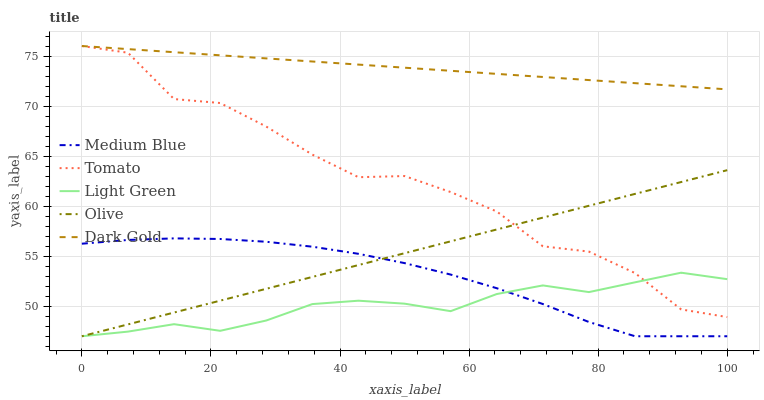Does Light Green have the minimum area under the curve?
Answer yes or no. Yes. Does Dark Gold have the maximum area under the curve?
Answer yes or no. Yes. Does Olive have the minimum area under the curve?
Answer yes or no. No. Does Olive have the maximum area under the curve?
Answer yes or no. No. Is Olive the smoothest?
Answer yes or no. Yes. Is Tomato the roughest?
Answer yes or no. Yes. Is Medium Blue the smoothest?
Answer yes or no. No. Is Medium Blue the roughest?
Answer yes or no. No. Does Olive have the lowest value?
Answer yes or no. Yes. Does Dark Gold have the lowest value?
Answer yes or no. No. Does Dark Gold have the highest value?
Answer yes or no. Yes. Does Olive have the highest value?
Answer yes or no. No. Is Olive less than Dark Gold?
Answer yes or no. Yes. Is Tomato greater than Medium Blue?
Answer yes or no. Yes. Does Light Green intersect Medium Blue?
Answer yes or no. Yes. Is Light Green less than Medium Blue?
Answer yes or no. No. Is Light Green greater than Medium Blue?
Answer yes or no. No. Does Olive intersect Dark Gold?
Answer yes or no. No. 